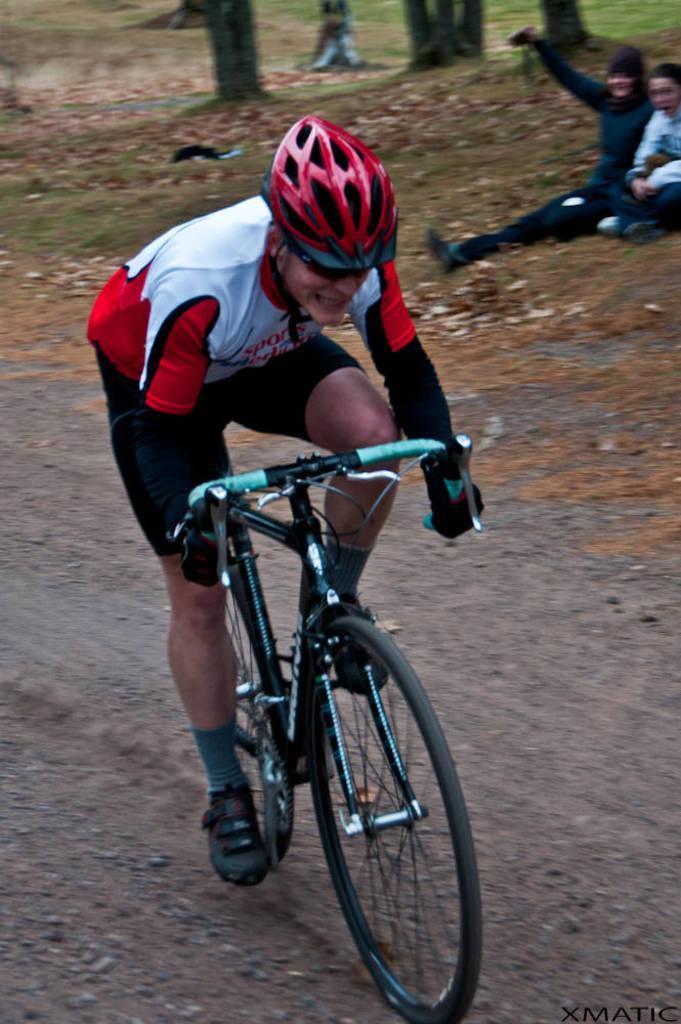Could you give a brief overview of what you see in this image? There is a man who is handicapped and riding the bicycle. At the background I can see two persons sitting. 